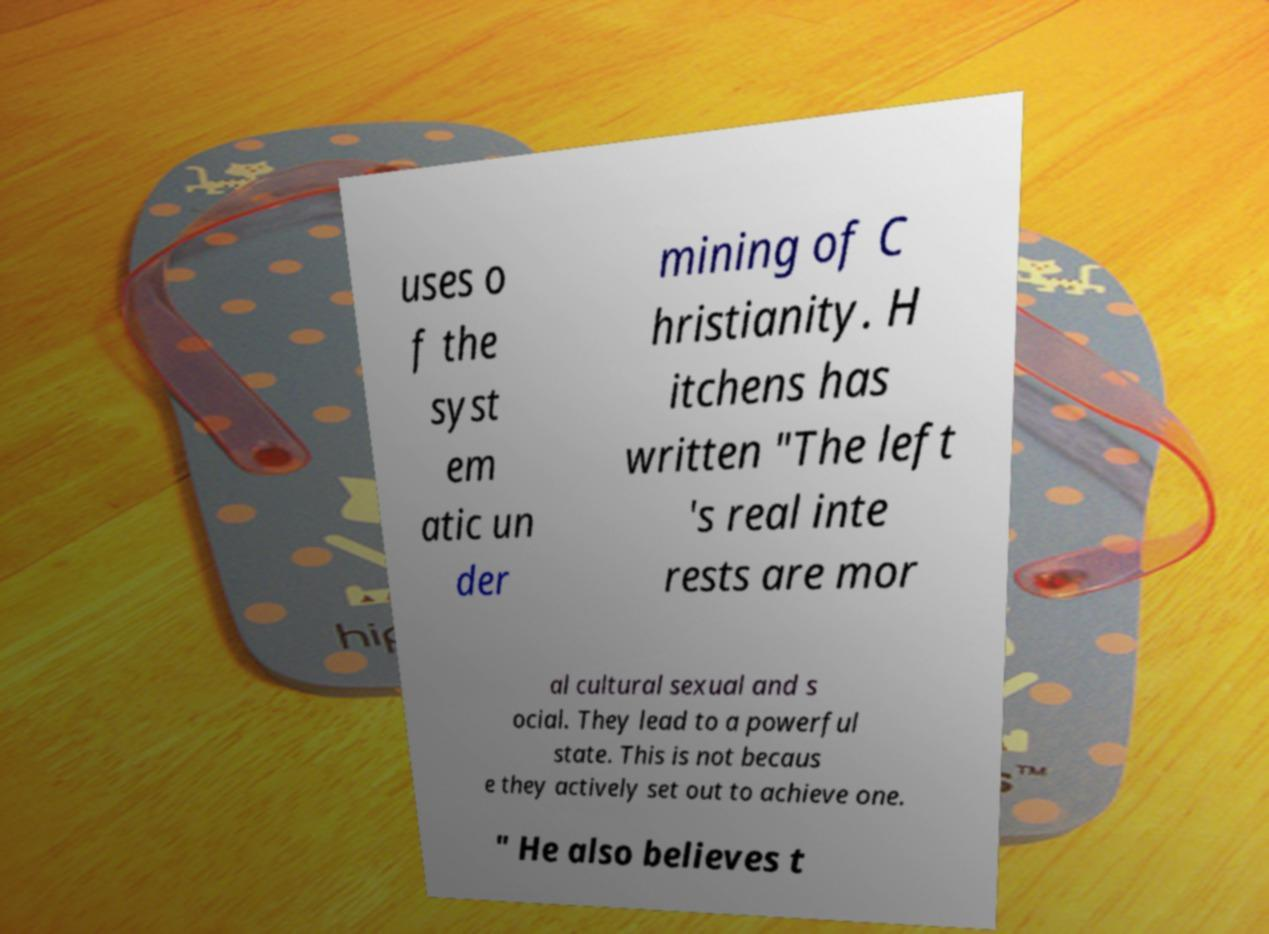Can you read and provide the text displayed in the image?This photo seems to have some interesting text. Can you extract and type it out for me? uses o f the syst em atic un der mining of C hristianity. H itchens has written "The left 's real inte rests are mor al cultural sexual and s ocial. They lead to a powerful state. This is not becaus e they actively set out to achieve one. " He also believes t 